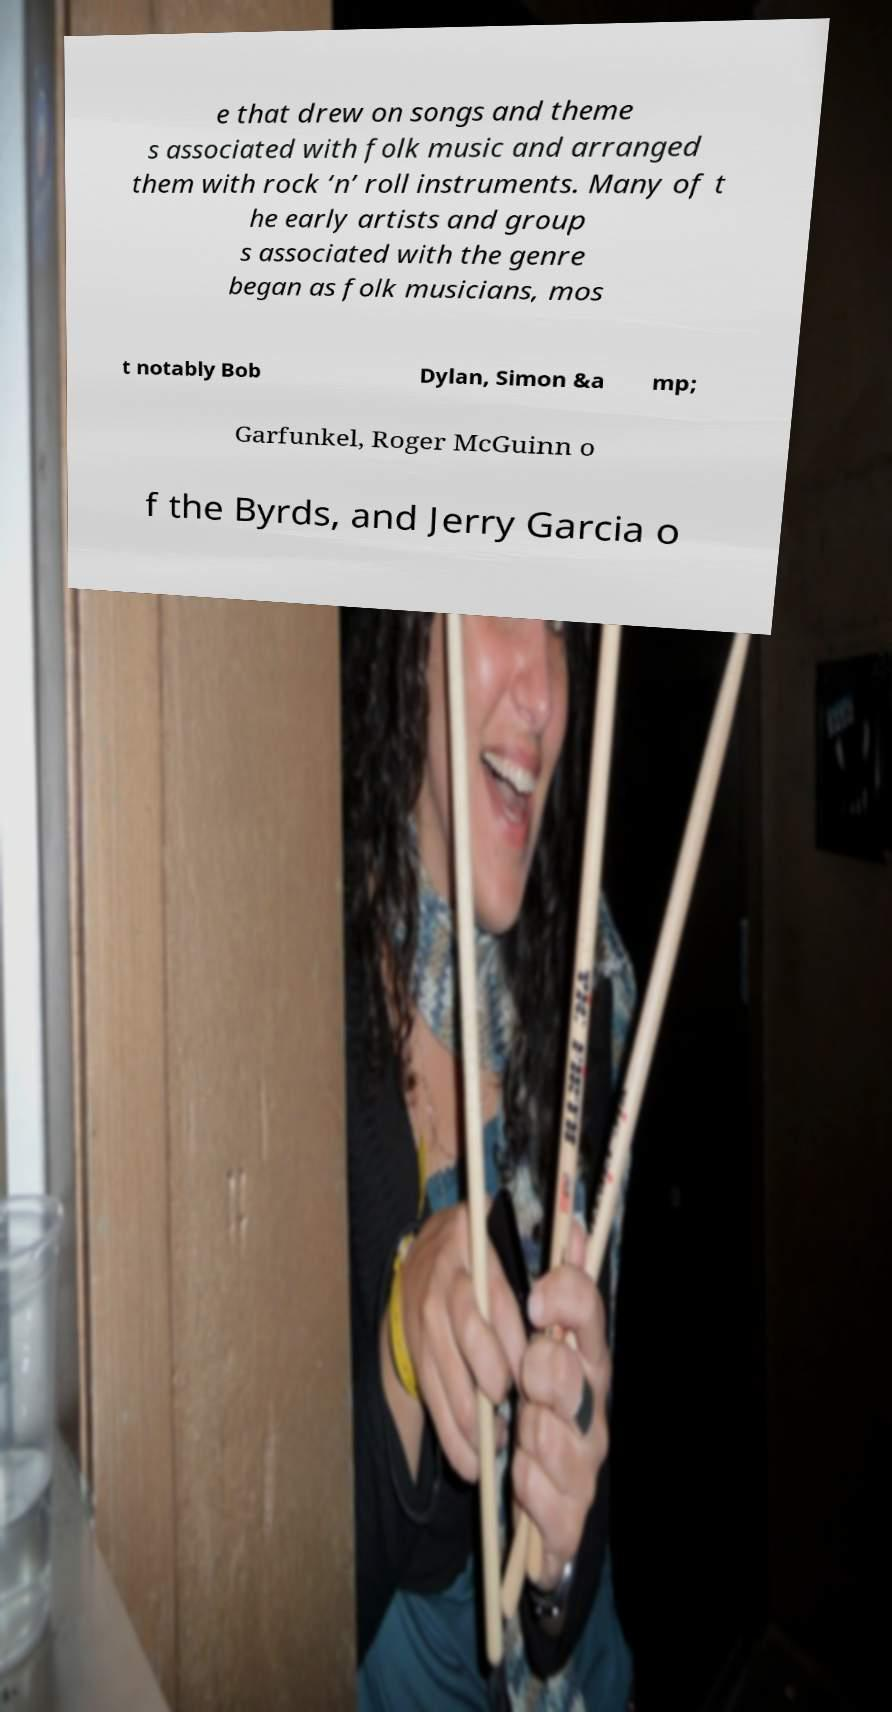Can you read and provide the text displayed in the image?This photo seems to have some interesting text. Can you extract and type it out for me? e that drew on songs and theme s associated with folk music and arranged them with rock ‘n’ roll instruments. Many of t he early artists and group s associated with the genre began as folk musicians, mos t notably Bob Dylan, Simon &a mp; Garfunkel, Roger McGuinn o f the Byrds, and Jerry Garcia o 